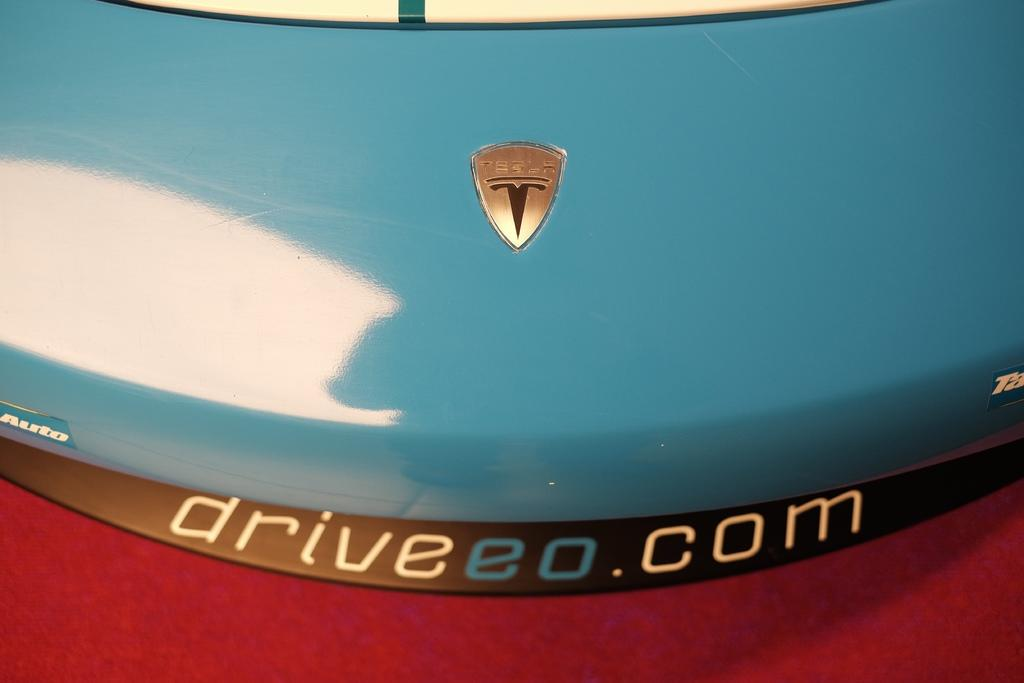What is the main subject in the center of the image? The center of the image features the front part of a car. What can be seen at the bottom of the image? There is a carpet at the bottom of the image. What type of yarn is being used to create the coach in the image? There is no coach or yarn present in the image; it features the front part of a car and a carpet. Is there an umbrella visible in the image? No, there is no umbrella present in the image. 